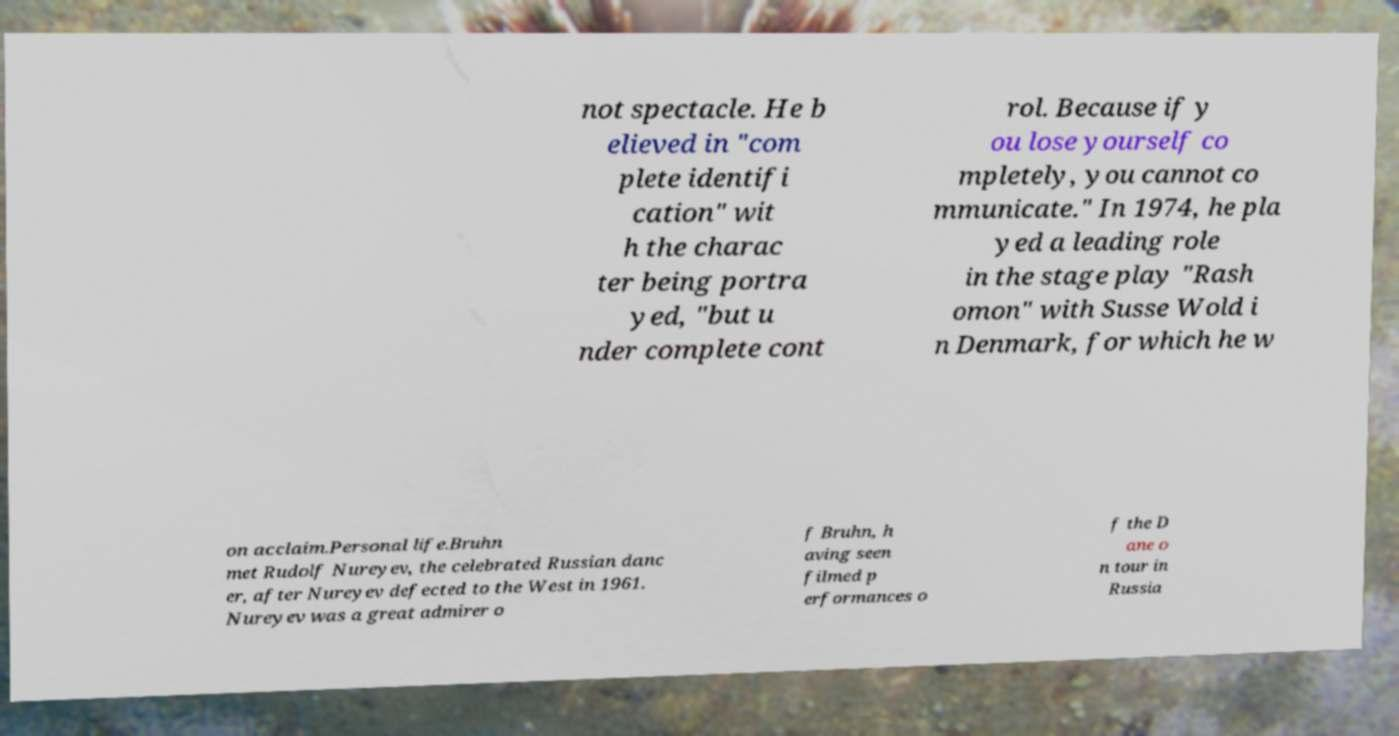For documentation purposes, I need the text within this image transcribed. Could you provide that? not spectacle. He b elieved in "com plete identifi cation" wit h the charac ter being portra yed, "but u nder complete cont rol. Because if y ou lose yourself co mpletely, you cannot co mmunicate." In 1974, he pla yed a leading role in the stage play "Rash omon" with Susse Wold i n Denmark, for which he w on acclaim.Personal life.Bruhn met Rudolf Nureyev, the celebrated Russian danc er, after Nureyev defected to the West in 1961. Nureyev was a great admirer o f Bruhn, h aving seen filmed p erformances o f the D ane o n tour in Russia 